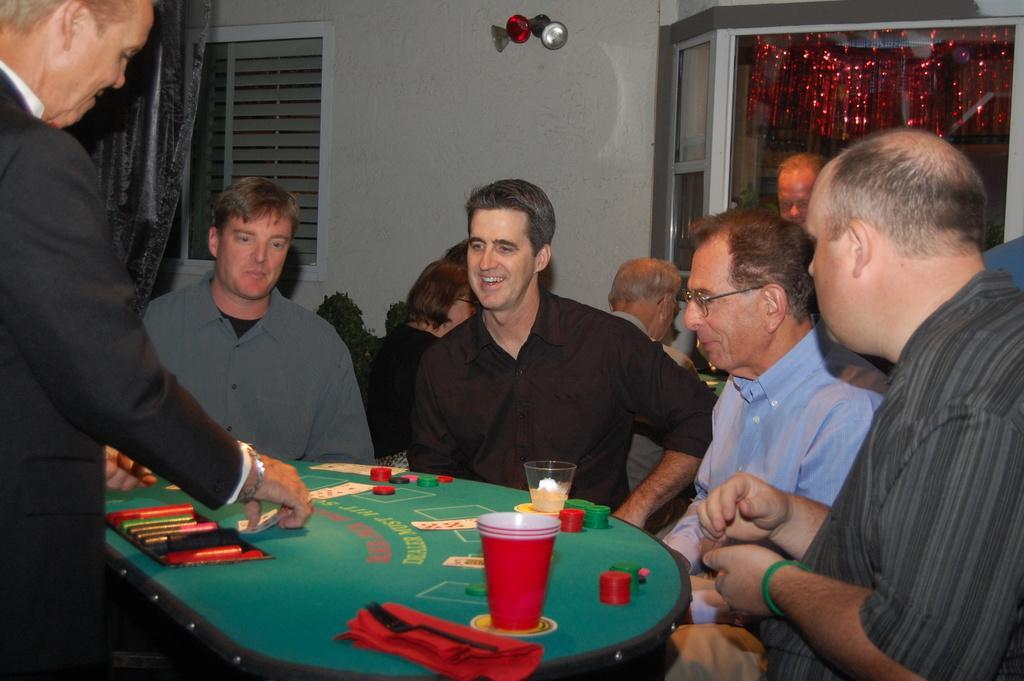Could you give a brief overview of what you see in this image? In this picture we can see five people sitting on the chairs in front of the table on which there are some glasses and some coins of a game. 